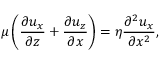<formula> <loc_0><loc_0><loc_500><loc_500>\mu \left ( \frac { \partial u _ { x } } { \partial z } + \frac { \partial u _ { z } } { \partial x } \right ) = \eta \frac { \partial ^ { 2 } u _ { x } } { \partial x ^ { 2 } } ,</formula> 